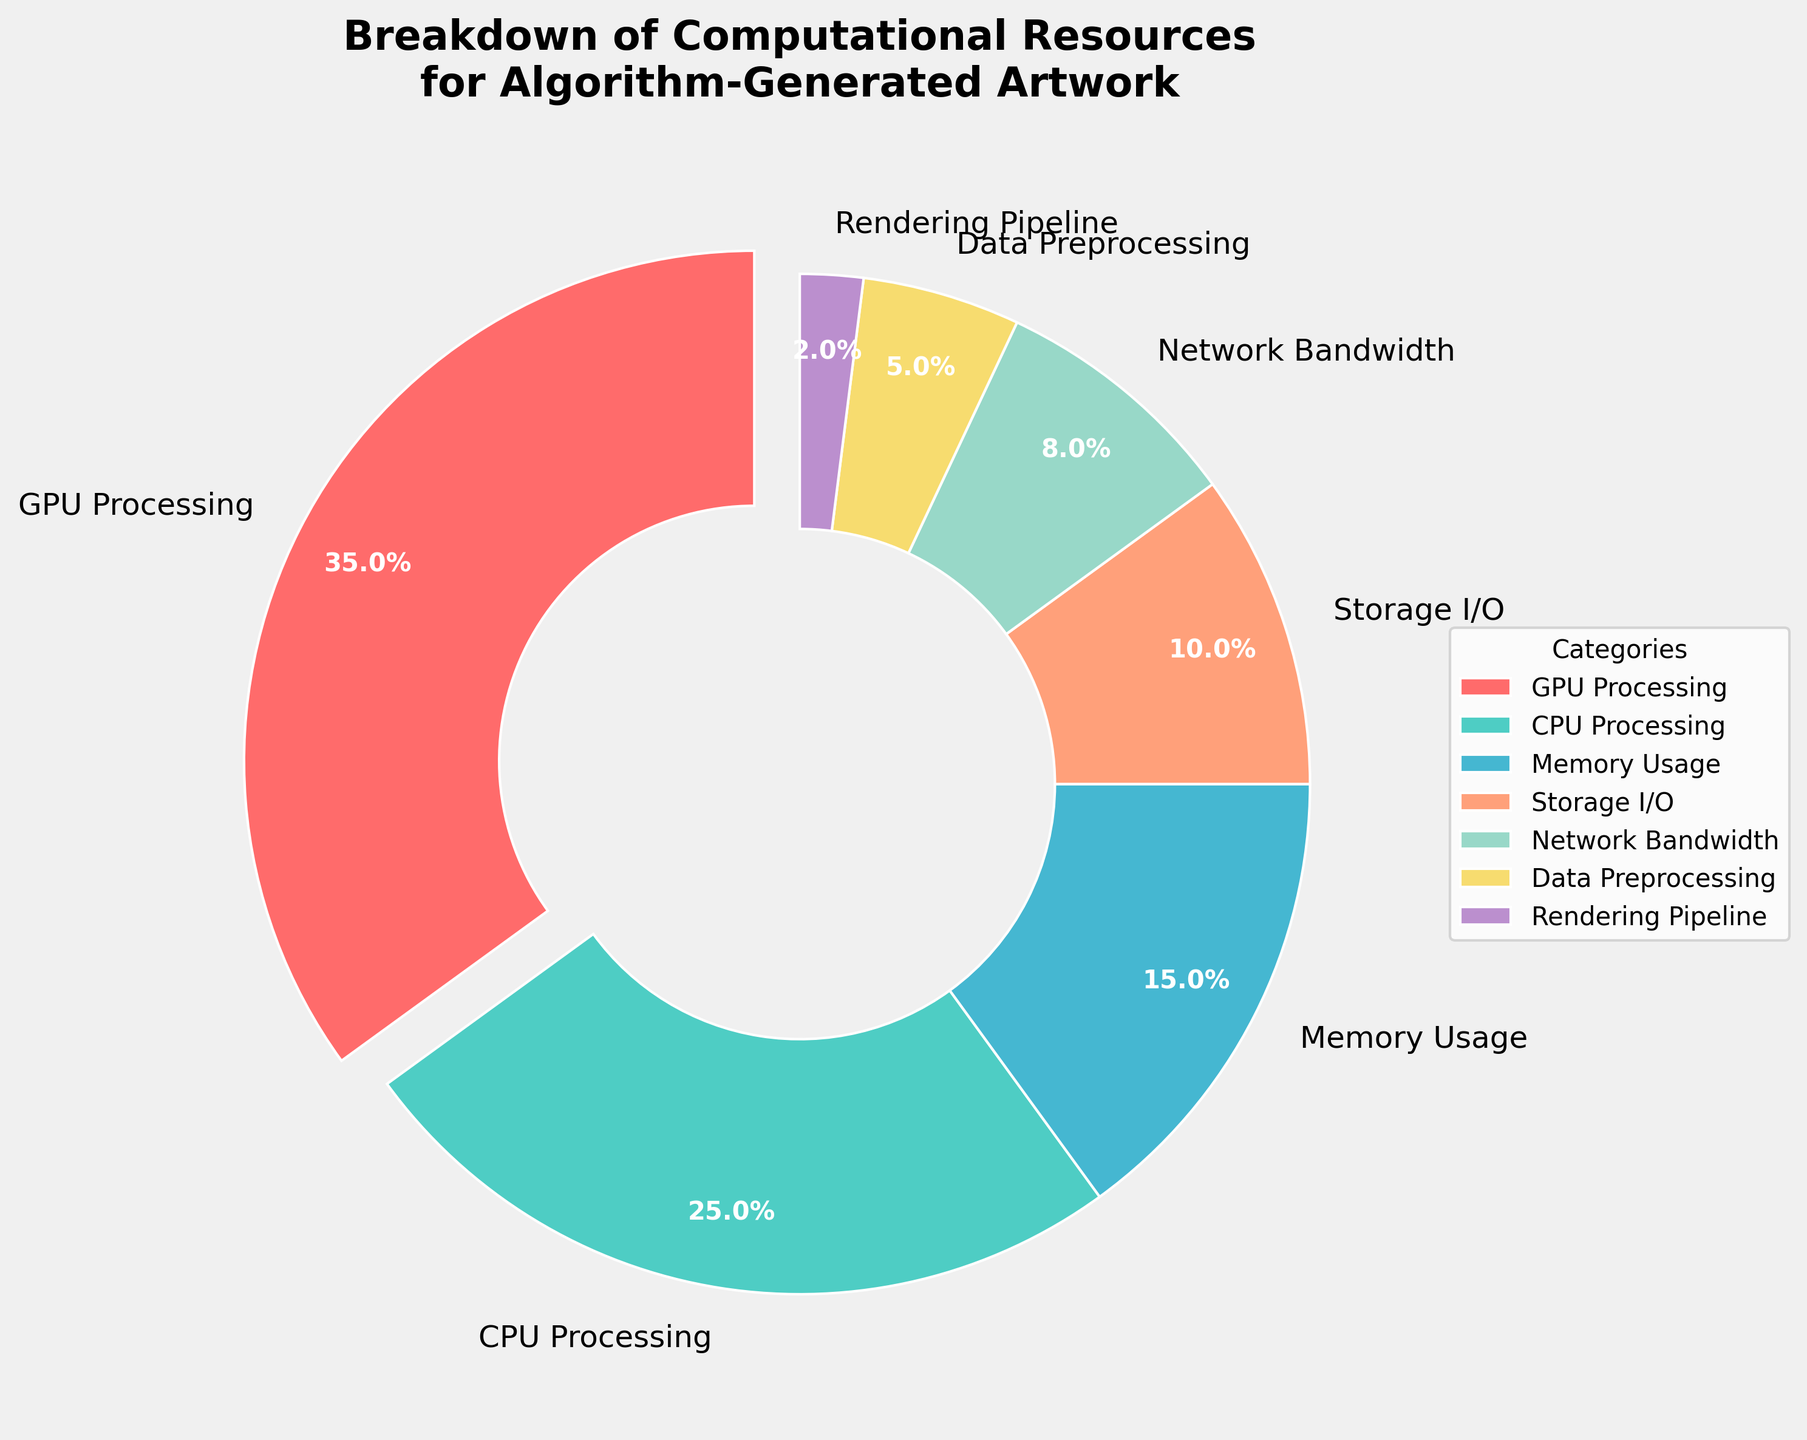Which category uses the largest percentage of resources? The largest percentage can be identified by looking for the largest slice in the pie chart. The GPU Processing category, with 35%, has the largest slice.
Answer: GPU Processing Which category uses less resources, CPU Processing or Network Bandwidth? By comparing the slices for CPU Processing and Network Bandwidth in the pie chart, CPU Processing uses 25%, and Network Bandwidth uses 8%. Since 8% is less than 25%, Network Bandwidth uses less resources.
Answer: Network Bandwidth What is the sum of the percentages for Memory Usage and Storage I/O? To find the sum, simply add the percentage values for Memory Usage (15%) and Storage I/O (10%). Hence, 15% + 10% = 25%.
Answer: 25% Which resource contributes more to the total usage: Data Preprocessing or Rendering Pipeline? By comparing the slices, Data Preprocessing uses 5%, and Rendering Pipeline uses 2%. Since 5% is greater than 2%, Data Preprocessing contributes more to the total usage.
Answer: Data Preprocessing What is the total percentage of resources used by GPU Processing, CPU Processing, and Memory Usage? To find the total, add the percentages of GPU Processing (35%), CPU Processing (25%), and Memory Usage (15%). Hence, 35% + 25% + 15% = 75%.
Answer: 75% Is the percentage of Network Bandwidth greater than or less than the sum of Rendering Pipeline and Data Preprocessing? Calculate the sum of Rendering Pipeline (2%) and Data Preprocessing (5%) which equals 7%. Network Bandwidth is 8%, so Network Bandwidth (8%) is greater than the sum of Rendering Pipeline and Data Preprocessing (7%).
Answer: Greater than Which two categories together use the least amount of resources? Identify the two smallest slices. Rendering Pipeline uses 2% and Data Preprocessing uses 5%. Adding these together, 2% + 5% = 7% which is the smallest combined value.
Answer: Rendering Pipeline and Data Preprocessing What is the difference in percentage between CPU Processing and Storage I/O? Subtract the smaller percentage (Storage I/O at 10%) from the larger percentage (CPU Processing at 25%). Thus, 25% - 10% = 15%.
Answer: 15% How does the percentage of Storage I/O compare to the percentage of Memory Usage visually? The Storage I/O (10%) slice is smaller than the Memory Usage (15%) slice, indicating Memory Usage uses a higher percentage of resources.
Answer: Memory Usage uses more What is the average percentage of the categories that make up less than 10% of the resources? Categories making up less than 10% are Storage I/O (10%), Network Bandwidth (8%), Data Preprocessing (5%), and Rendering Pipeline (2%). Summing these gives 10% + 8% + 5% + 2% = 25%. There are 4 such categories, so the average is 25% / 4 = 6.25%.
Answer: 6.25% 